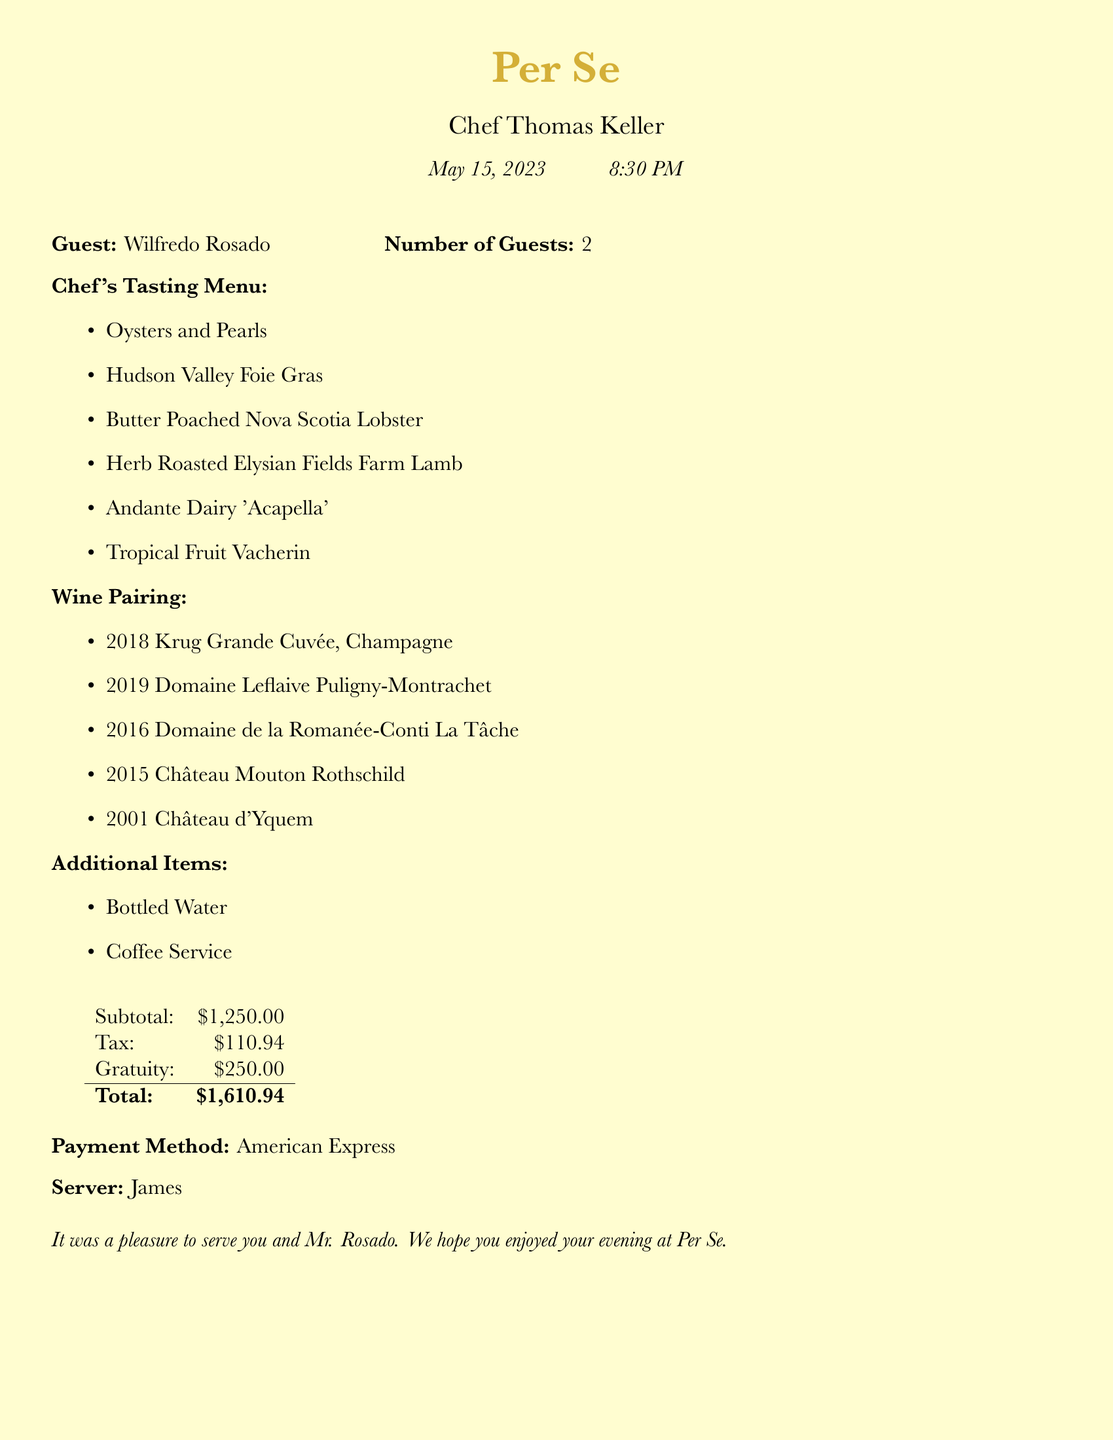What is the date of the dining experience? The date is provided in the header of the document, listed as May 15, 2023.
Answer: May 15, 2023 Who is the chef of the restaurant? The chef’s name is mentioned prominently in the document as Chef Thomas Keller.
Answer: Chef Thomas Keller What is the total amount of the bill? The total is calculated from the subtotal, tax, and gratuity listed in the document and is clearly stated as $1,610.94.
Answer: $1,610.94 How many guests were present? The number of guests is explicitly mentioned next to Wilfredo Rosado’s name, which indicates there were 2 guests.
Answer: 2 What wine was paired with the tasting menu? The document lists various wines in the wine pairing section; one specific wine mentioned is 2018 Krug Grande Cuvée.
Answer: 2018 Krug Grande Cuvée What type of payment method was used for the bill? The payment method is mentioned at the end of the document as American Express.
Answer: American Express What is the subtotal before tax and gratuity? The subtotal is listed in the breakdown of charges as $1,250.00.
Answer: $1,250.00 Who was the server for this dining experience? The name of the server is provided in the document and is listed as James.
Answer: James What additional items were ordered? The document contains a section listing extra items, where it mentions Bottled Water and Coffee Service.
Answer: Bottled Water, Coffee Service 